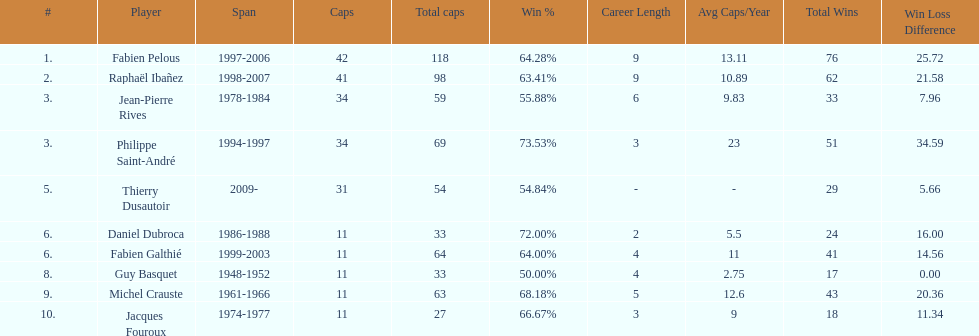Who had the largest win percentage? Philippe Saint-André. 